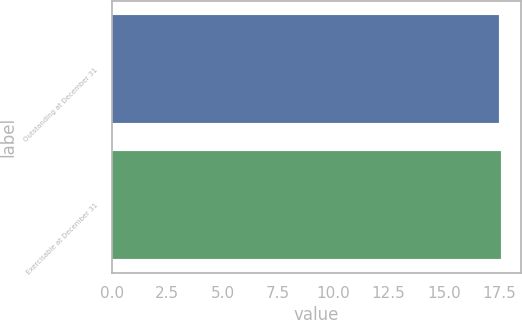Convert chart to OTSL. <chart><loc_0><loc_0><loc_500><loc_500><bar_chart><fcel>Outstanding at December 31<fcel>Exercisable at December 31<nl><fcel>17.5<fcel>17.6<nl></chart> 